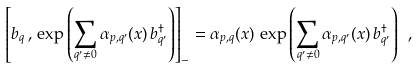Convert formula to latex. <formula><loc_0><loc_0><loc_500><loc_500>\left [ b _ { q } \, , \, \exp \left ( \sum _ { q ^ { \prime } \neq 0 } \alpha _ { p , q ^ { \prime } } ( x ) \, b ^ { \dagger } _ { q ^ { \prime } } \right ) \right ] _ { - } = \alpha _ { p , q } ( x ) \, \exp \left ( \sum _ { q ^ { \prime } \neq 0 } \alpha _ { p , q ^ { \prime } } ( x ) \, b ^ { \dagger } _ { q ^ { \prime } } \right ) \ ,</formula> 